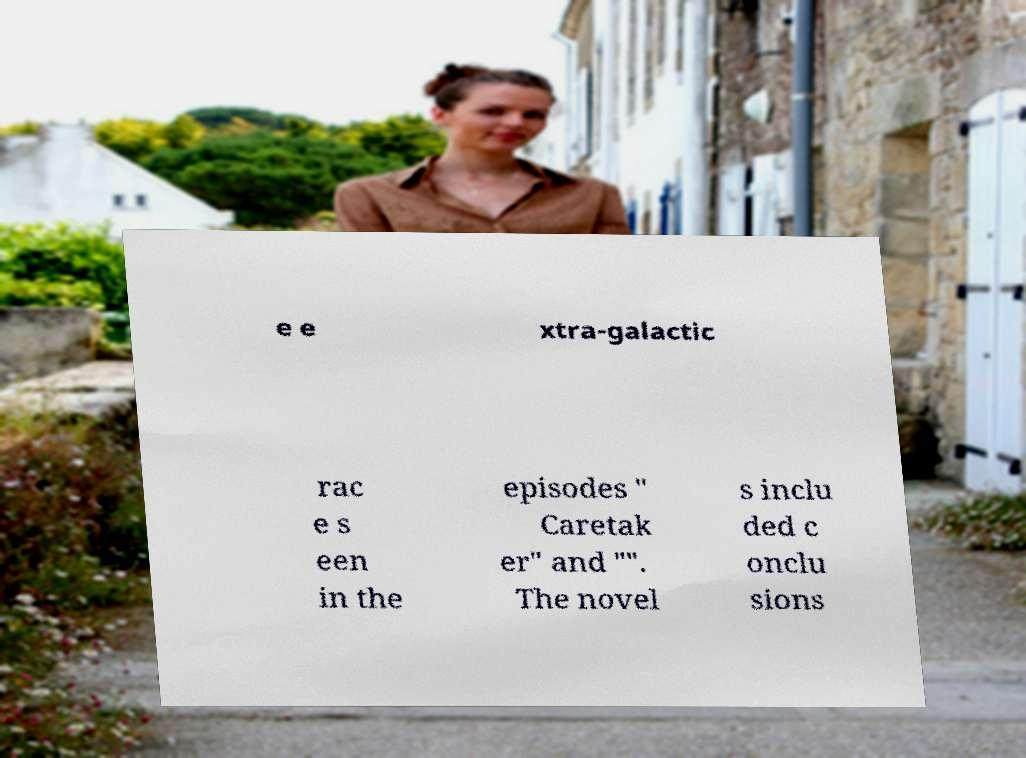Please identify and transcribe the text found in this image. e e xtra-galactic rac e s een in the episodes " Caretak er" and "". The novel s inclu ded c onclu sions 